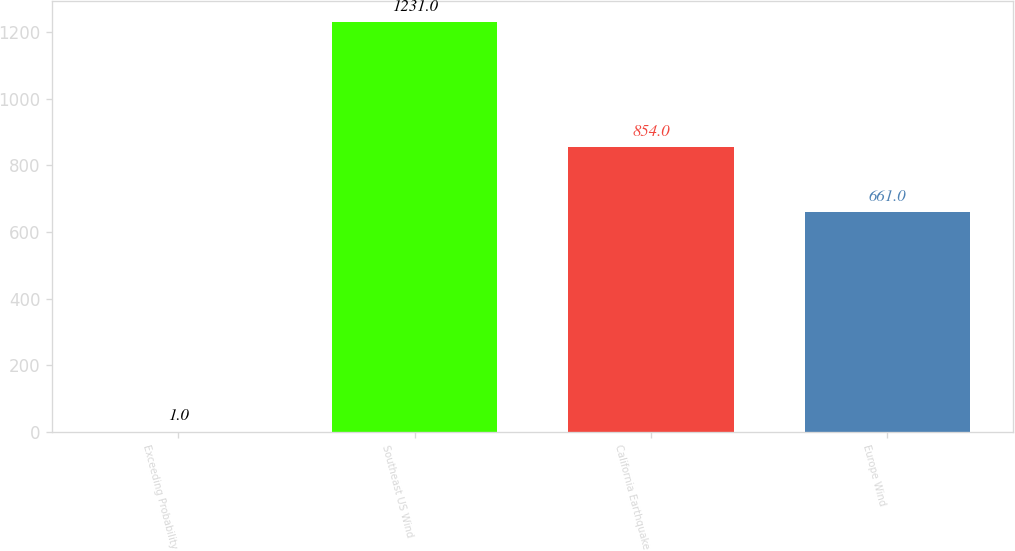Convert chart to OTSL. <chart><loc_0><loc_0><loc_500><loc_500><bar_chart><fcel>Exceeding Probability<fcel>Southeast US Wind<fcel>California Earthquake<fcel>Europe Wind<nl><fcel>1<fcel>1231<fcel>854<fcel>661<nl></chart> 